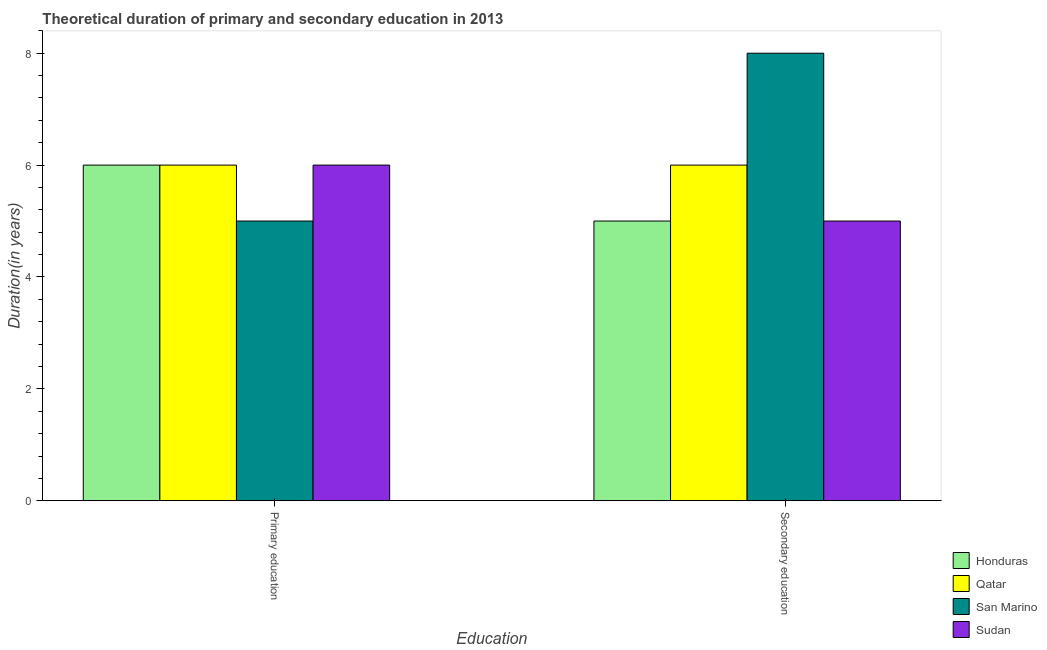How many different coloured bars are there?
Make the answer very short. 4. How many groups of bars are there?
Provide a short and direct response. 2. Are the number of bars per tick equal to the number of legend labels?
Give a very brief answer. Yes. How many bars are there on the 2nd tick from the left?
Keep it short and to the point. 4. How many bars are there on the 1st tick from the right?
Keep it short and to the point. 4. What is the label of the 2nd group of bars from the left?
Provide a short and direct response. Secondary education. What is the duration of primary education in San Marino?
Your answer should be very brief. 5. Across all countries, what is the maximum duration of secondary education?
Offer a terse response. 8. Across all countries, what is the minimum duration of primary education?
Ensure brevity in your answer.  5. In which country was the duration of primary education maximum?
Ensure brevity in your answer.  Honduras. In which country was the duration of secondary education minimum?
Your answer should be very brief. Honduras. What is the total duration of primary education in the graph?
Make the answer very short. 23. What is the difference between the duration of secondary education in San Marino and that in Qatar?
Your response must be concise. 2. What is the difference between the duration of secondary education in Sudan and the duration of primary education in Honduras?
Your response must be concise. -1. What is the average duration of primary education per country?
Your answer should be compact. 5.75. What is the difference between the duration of primary education and duration of secondary education in Honduras?
Provide a short and direct response. 1. In how many countries, is the duration of secondary education greater than 5.2 years?
Provide a short and direct response. 2. What is the ratio of the duration of secondary education in San Marino to that in Qatar?
Your response must be concise. 1.33. Is the duration of primary education in San Marino less than that in Honduras?
Your response must be concise. Yes. In how many countries, is the duration of secondary education greater than the average duration of secondary education taken over all countries?
Give a very brief answer. 1. What does the 1st bar from the left in Secondary education represents?
Ensure brevity in your answer.  Honduras. What does the 3rd bar from the right in Secondary education represents?
Provide a short and direct response. Qatar. How many bars are there?
Provide a short and direct response. 8. Does the graph contain any zero values?
Your response must be concise. No. Does the graph contain grids?
Give a very brief answer. No. Where does the legend appear in the graph?
Give a very brief answer. Bottom right. How many legend labels are there?
Provide a succinct answer. 4. How are the legend labels stacked?
Give a very brief answer. Vertical. What is the title of the graph?
Provide a succinct answer. Theoretical duration of primary and secondary education in 2013. What is the label or title of the X-axis?
Your answer should be compact. Education. What is the label or title of the Y-axis?
Offer a terse response. Duration(in years). What is the Duration(in years) of Qatar in Primary education?
Offer a very short reply. 6. What is the Duration(in years) in Qatar in Secondary education?
Offer a terse response. 6. Across all Education, what is the maximum Duration(in years) in Honduras?
Offer a terse response. 6. Across all Education, what is the maximum Duration(in years) in Qatar?
Give a very brief answer. 6. Across all Education, what is the minimum Duration(in years) of Qatar?
Your answer should be very brief. 6. Across all Education, what is the minimum Duration(in years) of Sudan?
Ensure brevity in your answer.  5. What is the total Duration(in years) in Honduras in the graph?
Your answer should be compact. 11. What is the total Duration(in years) of San Marino in the graph?
Your response must be concise. 13. What is the difference between the Duration(in years) of Sudan in Primary education and that in Secondary education?
Make the answer very short. 1. What is the difference between the Duration(in years) in Honduras in Primary education and the Duration(in years) in Sudan in Secondary education?
Provide a succinct answer. 1. What is the difference between the Duration(in years) of Qatar in Primary education and the Duration(in years) of Sudan in Secondary education?
Your answer should be very brief. 1. What is the average Duration(in years) in Honduras per Education?
Provide a short and direct response. 5.5. What is the average Duration(in years) in Qatar per Education?
Your response must be concise. 6. What is the average Duration(in years) of San Marino per Education?
Provide a short and direct response. 6.5. What is the average Duration(in years) in Sudan per Education?
Offer a terse response. 5.5. What is the difference between the Duration(in years) of Honduras and Duration(in years) of Qatar in Primary education?
Provide a succinct answer. 0. What is the difference between the Duration(in years) of Qatar and Duration(in years) of San Marino in Primary education?
Provide a succinct answer. 1. What is the difference between the Duration(in years) of Qatar and Duration(in years) of Sudan in Primary education?
Your answer should be compact. 0. What is the difference between the Duration(in years) of Honduras and Duration(in years) of San Marino in Secondary education?
Offer a very short reply. -3. What is the difference between the Duration(in years) of Honduras and Duration(in years) of Sudan in Secondary education?
Your answer should be very brief. 0. What is the difference between the Duration(in years) of Qatar and Duration(in years) of San Marino in Secondary education?
Your response must be concise. -2. What is the difference between the Duration(in years) of San Marino and Duration(in years) of Sudan in Secondary education?
Make the answer very short. 3. What is the ratio of the Duration(in years) in Honduras in Primary education to that in Secondary education?
Ensure brevity in your answer.  1.2. What is the ratio of the Duration(in years) of San Marino in Primary education to that in Secondary education?
Provide a short and direct response. 0.62. What is the difference between the highest and the lowest Duration(in years) in Honduras?
Keep it short and to the point. 1. What is the difference between the highest and the lowest Duration(in years) in San Marino?
Your answer should be compact. 3. 